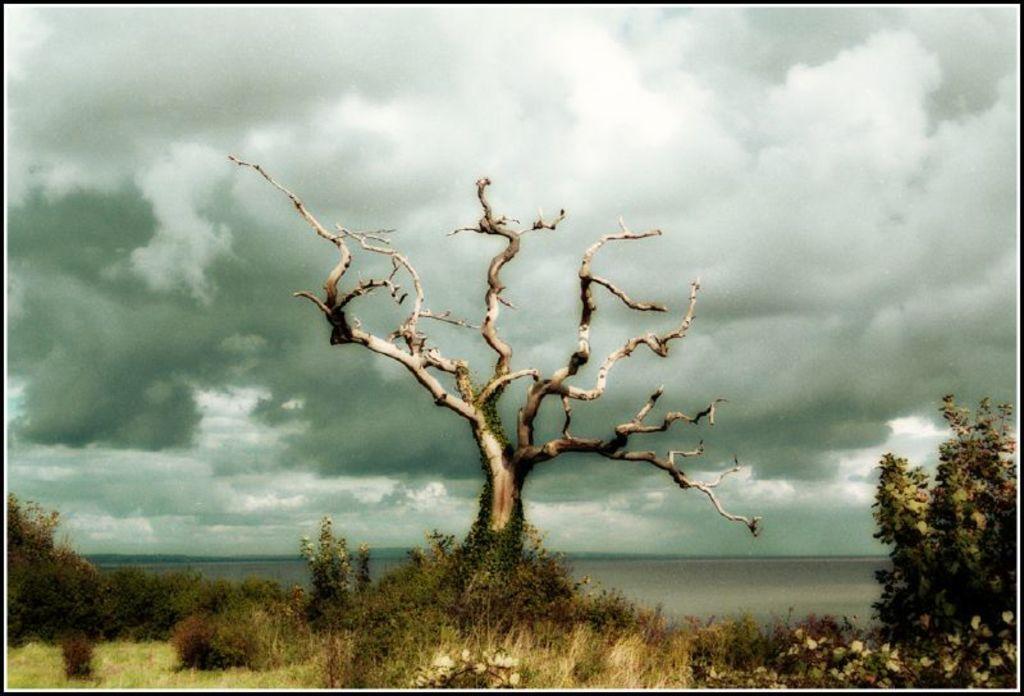In one or two sentences, can you explain what this image depicts? Here, we can see some plants and trees, at the top there is a sky which is cloudy. 